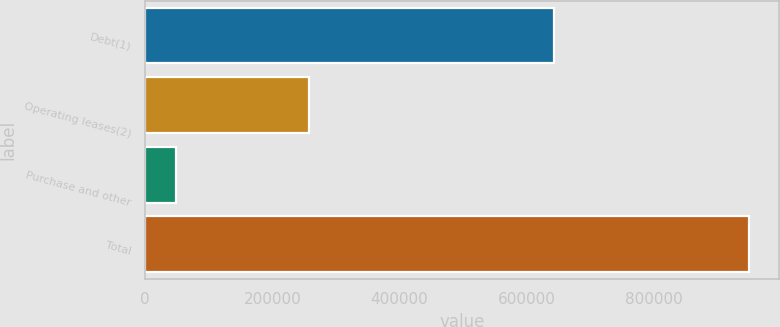<chart> <loc_0><loc_0><loc_500><loc_500><bar_chart><fcel>Debt(1)<fcel>Operating leases(2)<fcel>Purchase and other<fcel>Total<nl><fcel>642638<fcel>257222<fcel>48983<fcel>948843<nl></chart> 